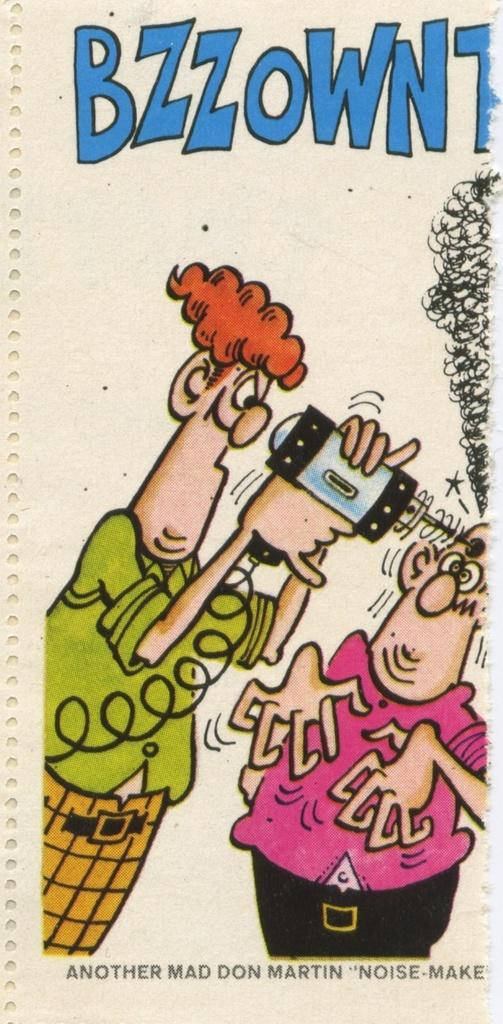What is the main object in the image? There is a paper present in the image. What can be seen on the paper? There are animated pictures on the paper. Are there any words or letters on the paper? Yes, there is text on the paper. What type of punishment is being depicted in the animated pictures on the paper? There is no punishment being depicted in the animated pictures on the paper; they are not related to any form of punishment. 